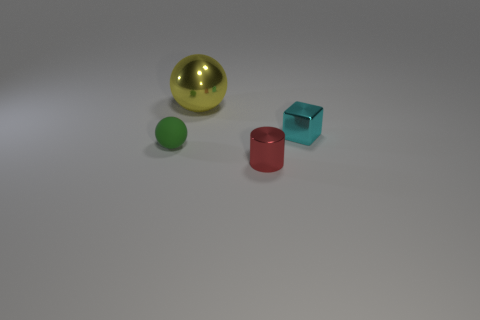Is there any other thing that is the same color as the block?
Offer a terse response. No. There is a large object that is the same material as the small cyan cube; what shape is it?
Give a very brief answer. Sphere. Are there fewer rubber objects to the right of the big yellow sphere than large yellow objects?
Your response must be concise. Yes. Is the shape of the red metallic thing the same as the cyan metallic object?
Offer a terse response. No. What number of metallic things are big yellow balls or purple cylinders?
Offer a very short reply. 1. Is there a green thing that has the same size as the green rubber ball?
Give a very brief answer. No. How many red metal objects are the same size as the green sphere?
Provide a short and direct response. 1. Does the metal object that is in front of the cyan metal thing have the same size as the thing on the right side of the red thing?
Offer a very short reply. Yes. What number of things are either brown matte objects or spheres that are to the left of the big metallic thing?
Your answer should be very brief. 1. The tiny metal block is what color?
Offer a very short reply. Cyan. 